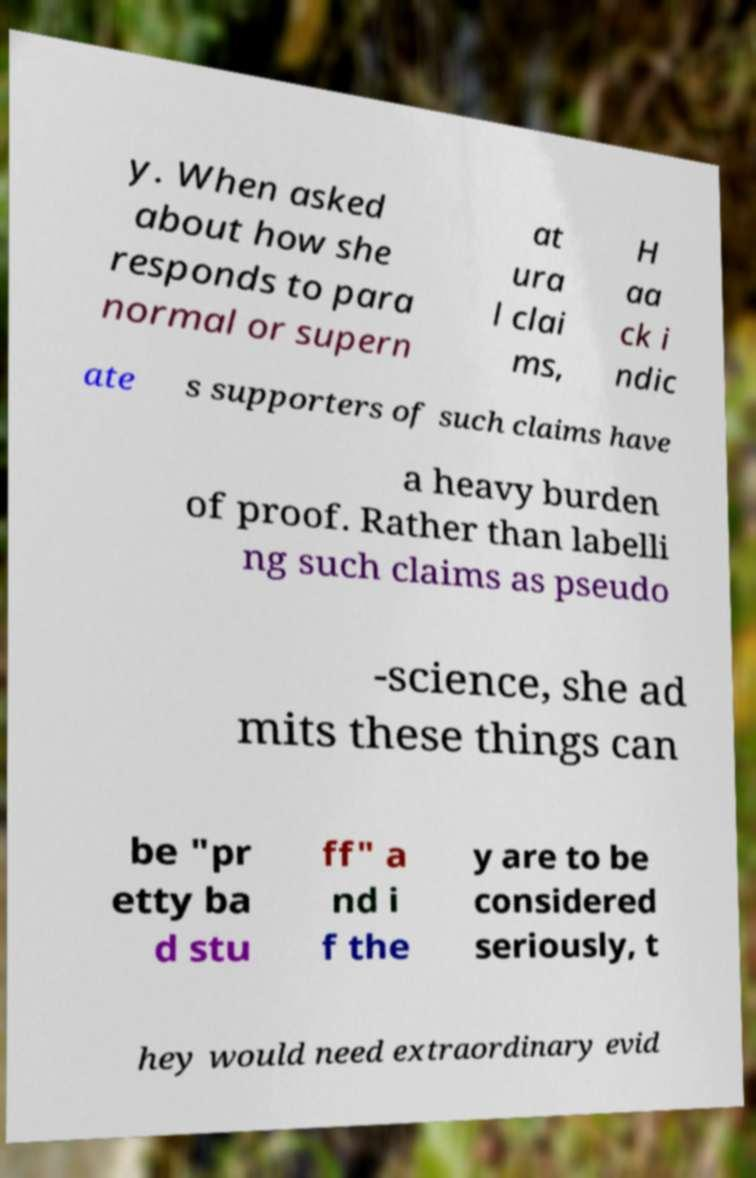Could you assist in decoding the text presented in this image and type it out clearly? y. When asked about how she responds to para normal or supern at ura l clai ms, H aa ck i ndic ate s supporters of such claims have a heavy burden of proof. Rather than labelli ng such claims as pseudo -science, she ad mits these things can be "pr etty ba d stu ff" a nd i f the y are to be considered seriously, t hey would need extraordinary evid 